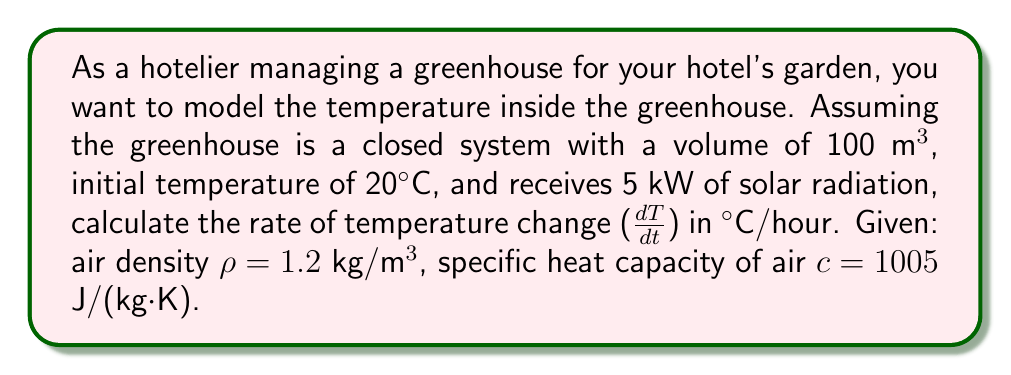Show me your answer to this math problem. To solve this problem, we'll use the first law of thermodynamics and the definition of specific heat capacity:

1) The first law of thermodynamics for a closed system:
   $$\frac{dU}{dt} = Q - W$$
   Where $\frac{dU}{dt}$ is the rate of change of internal energy, $Q$ is the heat input, and $W$ is the work done.

2) In this case, there's no work done, so $W = 0$. The heat input $Q$ is given as 5 kW or 5000 J/s.

3) The change in internal energy is related to temperature change by:
   $$\frac{dU}{dt} = mc\frac{dT}{dt}$$
   Where $m$ is the mass of air, $c$ is the specific heat capacity, and $\frac{dT}{dt}$ is the rate of temperature change.

4) The mass of air in the greenhouse:
   $$m = \rho V = 1.2 \text{ kg/m³} \times 100 \text{ m³} = 120 \text{ kg}$$

5) Substituting into the first law of thermodynamics:
   $$mc\frac{dT}{dt} = Q$$

6) Rearranging to solve for $\frac{dT}{dt}$:
   $$\frac{dT}{dt} = \frac{Q}{mc} = \frac{5000 \text{ J/s}}{120 \text{ kg} \times 1005 \text{ J/(kg·K)}} = 0.0414 \text{ K/s}$$

7) Converting to °C/hour:
   $$0.0414 \text{ K/s} \times 3600 \text{ s/hour} = 149.04 \text{ °C/hour}$$
Answer: 149.04 °C/hour 